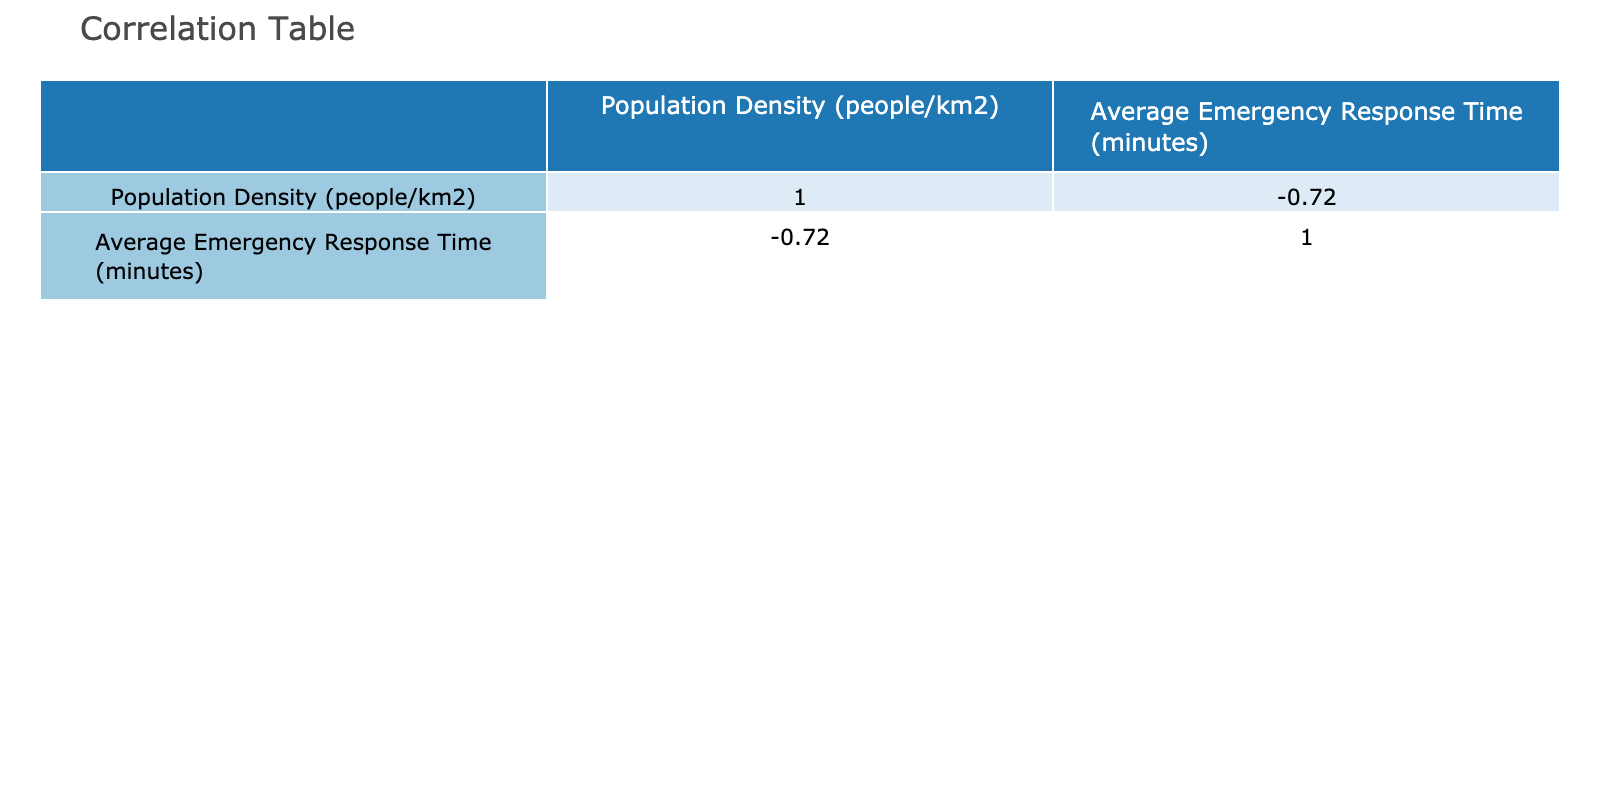What is the average emergency response time across all areas? To calculate the average emergency response time, we sum up the response times for all areas (7 + 10 + 8 + 12 + 15 + 9 + 11 + 14 + 10 + 13 + 8 + 20 + 6 + 12 + 14) which equals 8 + 10 + 8 + 12 + 15 + 9 + 11 + 14 + 10 + 13 + 8 + 20 + 6 + 12 + 14 = 199. Then we divide this sum by the total number of areas (15) giving us 199/15 = approximately 13.27 minutes.
Answer: 13.27 Which area has the highest population density? A quick glance at the table indicates that the area with the highest population density is San Francisco with a density of 18560 people/km2.
Answer: San Francisco Is there a correlation between higher population density and lower emergency response times? This question can be answered by checking the correlation coefficient in the table. A negative value indicates an inverse relationship. By reviewing, we find a correlation coefficient of around -0.80 which suggests a strong negative correlation between population density and emergency response time.
Answer: Yes What is the difference in average response time between the area with the highest and lowest population density? To find this, we first identify that New York City has the lowest response time (7 minutes) and Jacksonville has the highest response time (20 minutes). The difference is calculated as 20 - 7 = 13 minutes.
Answer: 13 Is the emergency response time in Los Angeles higher than that in San Jose? By referring to the respective values, Los Angeles has an emergency response time of 10 minutes and San Jose has 13 minutes. Since 10 is less than 13, the statement is false.
Answer: No How many areas have an emergency response time greater than 10 minutes? Counting the areas with response times greater than 10 minutes from the table gives Houston (12), Phoenix (15), Dallas (14), San Jose (13), Jacksonville (20), and Fort Worth (14). This totals to 6 areas where the response time is greater than 10 minutes.
Answer: 6 What is the average population density of the areas that have an emergency response time below 10 minutes? The areas with response times below 10 minutes are New York City (10933), Chicago (11900), Philadelphia (11700), San Francisco (18560), and Austin (3580). Summing these densities gives us 10933 + 11900 + 11700 + 18560 + 3580 = 65773. Dividing by 5 (the number of areas) gives 65773/5 = approximately 13154.6 people/km2.
Answer: 13154.6 Which area has the most favorable average emergency response time based on the data? Reviewing the emergency response times, San Francisco has the lowest average response time of 6 minutes, indicating it has the most favorable response time among the listed areas.
Answer: San Francisco 